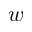Convert formula to latex. <formula><loc_0><loc_0><loc_500><loc_500>w</formula> 